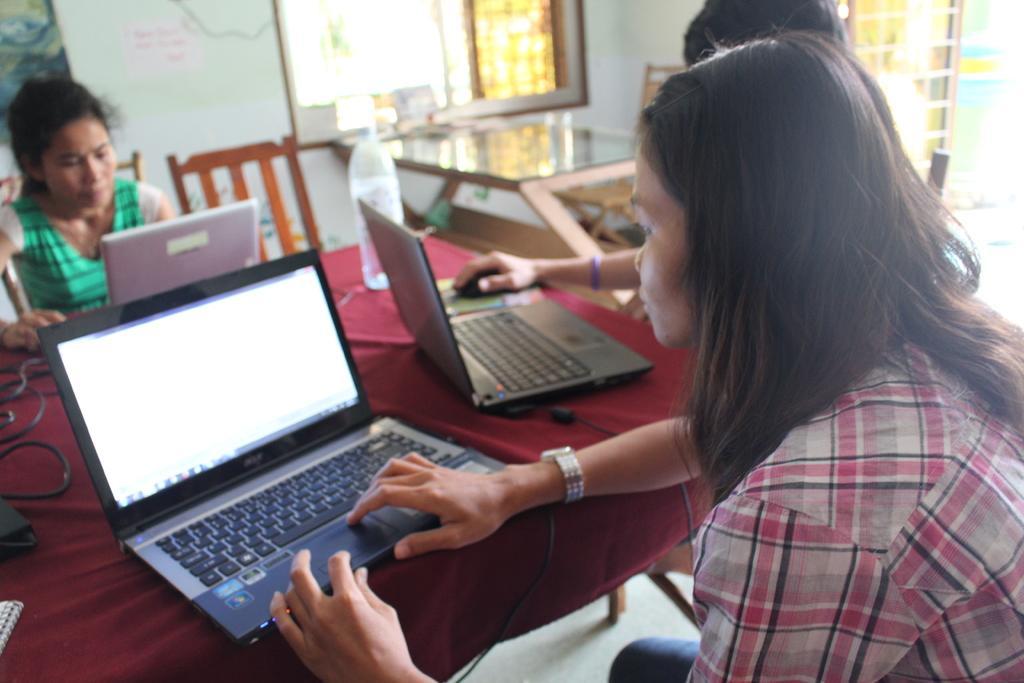How would you summarize this image in a sentence or two? This picture is clicked inside the room. In this picture, we see three women are sitting on the chairs. In front of them, we see a table on which laptops, cables and water bottle are placed. This table is covered with the maroon color cloth. Behind them, we see a glass table and chairs. In the background, we see a white wall on which poster is pasted. In the right top, we see a door. We even see the window. 